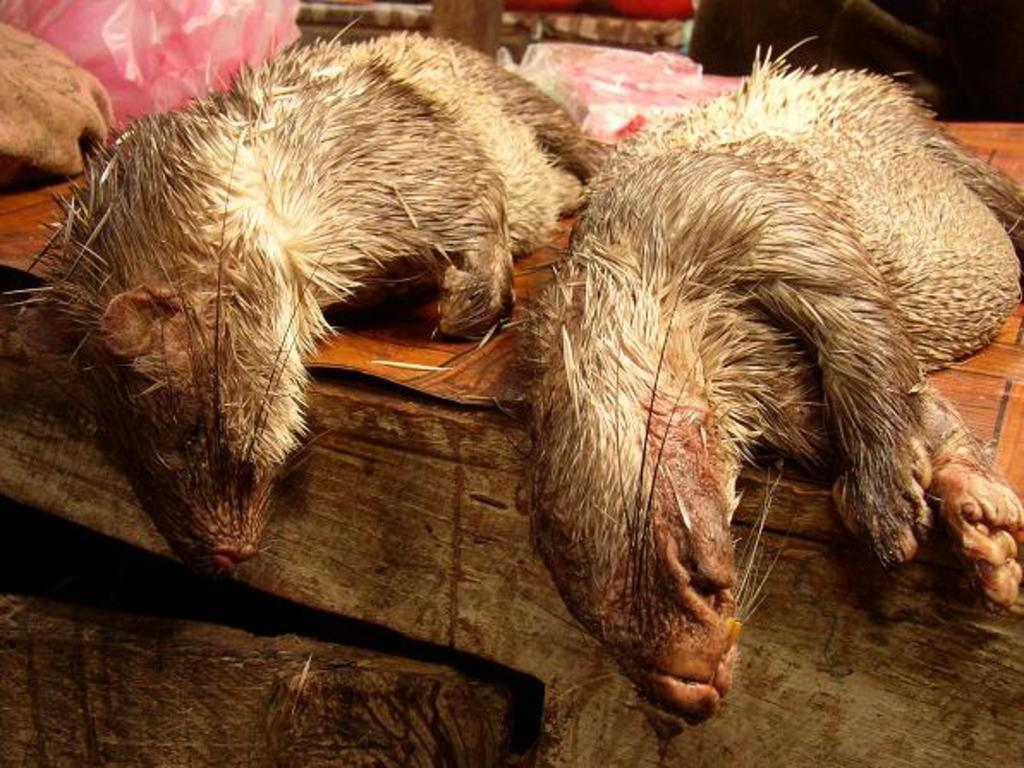What is located in the foreground of the picture? There are two animals in the foreground of the picture. What are the animals standing on? The animals are on a wooden object. What can be seen in the background of the image? There are covered objects and other objects in the background of the image. What type of book is the animal reading in the image? There is no book or reading activity present in the image. 